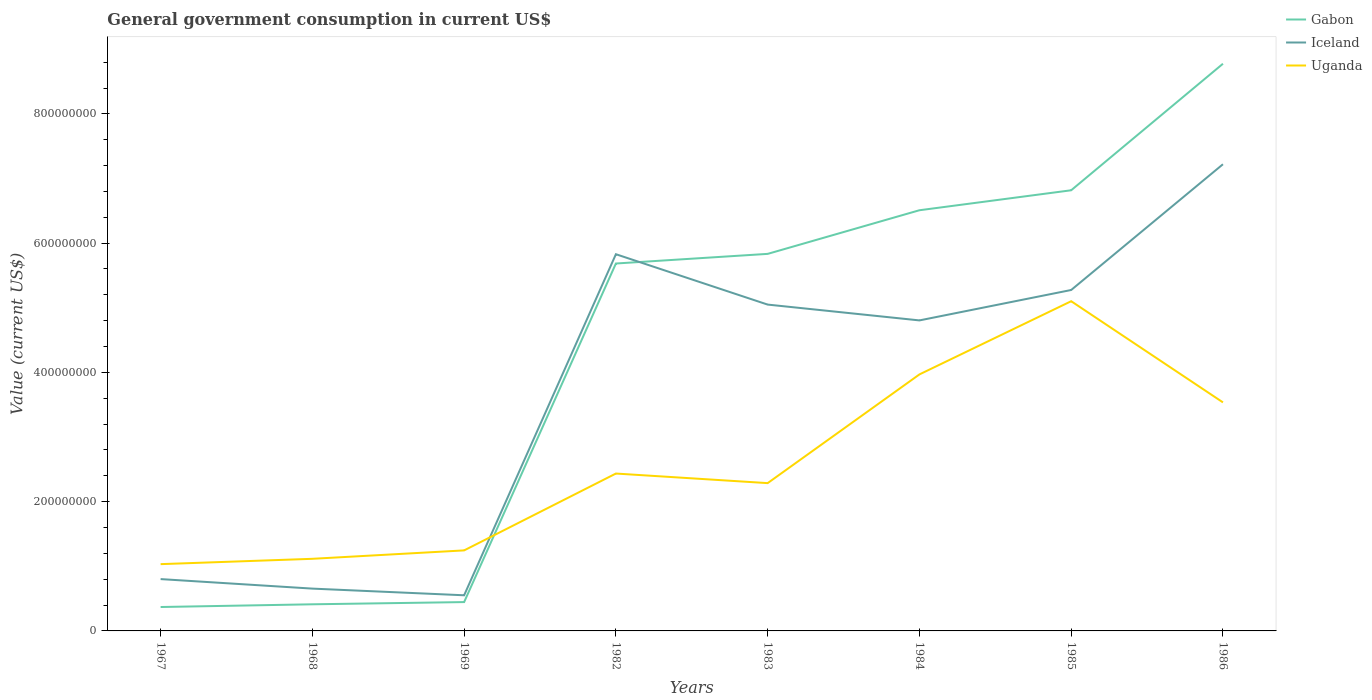Does the line corresponding to Iceland intersect with the line corresponding to Uganda?
Provide a short and direct response. Yes. Across all years, what is the maximum government conusmption in Gabon?
Provide a short and direct response. 3.70e+07. In which year was the government conusmption in Uganda maximum?
Your response must be concise. 1967. What is the total government conusmption in Iceland in the graph?
Give a very brief answer. 1.03e+07. What is the difference between the highest and the second highest government conusmption in Gabon?
Your response must be concise. 8.41e+08. Is the government conusmption in Uganda strictly greater than the government conusmption in Iceland over the years?
Make the answer very short. No. How many years are there in the graph?
Provide a succinct answer. 8. What is the difference between two consecutive major ticks on the Y-axis?
Make the answer very short. 2.00e+08. Does the graph contain any zero values?
Keep it short and to the point. No. Does the graph contain grids?
Give a very brief answer. No. Where does the legend appear in the graph?
Your answer should be compact. Top right. How many legend labels are there?
Give a very brief answer. 3. How are the legend labels stacked?
Offer a terse response. Vertical. What is the title of the graph?
Your answer should be compact. General government consumption in current US$. What is the label or title of the Y-axis?
Your response must be concise. Value (current US$). What is the Value (current US$) in Gabon in 1967?
Make the answer very short. 3.70e+07. What is the Value (current US$) of Iceland in 1967?
Your answer should be compact. 8.02e+07. What is the Value (current US$) in Uganda in 1967?
Keep it short and to the point. 1.03e+08. What is the Value (current US$) of Gabon in 1968?
Make the answer very short. 4.12e+07. What is the Value (current US$) in Iceland in 1968?
Give a very brief answer. 6.55e+07. What is the Value (current US$) of Uganda in 1968?
Offer a terse response. 1.12e+08. What is the Value (current US$) of Gabon in 1969?
Your answer should be compact. 4.46e+07. What is the Value (current US$) in Iceland in 1969?
Offer a terse response. 5.51e+07. What is the Value (current US$) of Uganda in 1969?
Ensure brevity in your answer.  1.25e+08. What is the Value (current US$) of Gabon in 1982?
Provide a short and direct response. 5.68e+08. What is the Value (current US$) in Iceland in 1982?
Provide a short and direct response. 5.83e+08. What is the Value (current US$) in Uganda in 1982?
Offer a very short reply. 2.44e+08. What is the Value (current US$) of Gabon in 1983?
Offer a very short reply. 5.83e+08. What is the Value (current US$) in Iceland in 1983?
Ensure brevity in your answer.  5.05e+08. What is the Value (current US$) in Uganda in 1983?
Provide a succinct answer. 2.29e+08. What is the Value (current US$) in Gabon in 1984?
Offer a very short reply. 6.51e+08. What is the Value (current US$) in Iceland in 1984?
Your answer should be compact. 4.80e+08. What is the Value (current US$) of Uganda in 1984?
Give a very brief answer. 3.97e+08. What is the Value (current US$) of Gabon in 1985?
Keep it short and to the point. 6.82e+08. What is the Value (current US$) of Iceland in 1985?
Your response must be concise. 5.27e+08. What is the Value (current US$) of Uganda in 1985?
Make the answer very short. 5.10e+08. What is the Value (current US$) of Gabon in 1986?
Offer a terse response. 8.78e+08. What is the Value (current US$) of Iceland in 1986?
Keep it short and to the point. 7.22e+08. What is the Value (current US$) in Uganda in 1986?
Provide a short and direct response. 3.54e+08. Across all years, what is the maximum Value (current US$) of Gabon?
Give a very brief answer. 8.78e+08. Across all years, what is the maximum Value (current US$) of Iceland?
Keep it short and to the point. 7.22e+08. Across all years, what is the maximum Value (current US$) of Uganda?
Provide a succinct answer. 5.10e+08. Across all years, what is the minimum Value (current US$) in Gabon?
Your answer should be compact. 3.70e+07. Across all years, what is the minimum Value (current US$) in Iceland?
Give a very brief answer. 5.51e+07. Across all years, what is the minimum Value (current US$) of Uganda?
Make the answer very short. 1.03e+08. What is the total Value (current US$) of Gabon in the graph?
Provide a short and direct response. 3.48e+09. What is the total Value (current US$) of Iceland in the graph?
Provide a short and direct response. 3.02e+09. What is the total Value (current US$) of Uganda in the graph?
Offer a very short reply. 2.07e+09. What is the difference between the Value (current US$) of Gabon in 1967 and that in 1968?
Your answer should be compact. -4.21e+06. What is the difference between the Value (current US$) of Iceland in 1967 and that in 1968?
Your answer should be compact. 1.47e+07. What is the difference between the Value (current US$) in Uganda in 1967 and that in 1968?
Provide a short and direct response. -8.26e+06. What is the difference between the Value (current US$) in Gabon in 1967 and that in 1969?
Your answer should be compact. -7.63e+06. What is the difference between the Value (current US$) of Iceland in 1967 and that in 1969?
Your answer should be compact. 2.50e+07. What is the difference between the Value (current US$) of Uganda in 1967 and that in 1969?
Provide a succinct answer. -2.13e+07. What is the difference between the Value (current US$) in Gabon in 1967 and that in 1982?
Keep it short and to the point. -5.31e+08. What is the difference between the Value (current US$) in Iceland in 1967 and that in 1982?
Ensure brevity in your answer.  -5.03e+08. What is the difference between the Value (current US$) in Uganda in 1967 and that in 1982?
Give a very brief answer. -1.40e+08. What is the difference between the Value (current US$) in Gabon in 1967 and that in 1983?
Provide a succinct answer. -5.46e+08. What is the difference between the Value (current US$) of Iceland in 1967 and that in 1983?
Provide a succinct answer. -4.25e+08. What is the difference between the Value (current US$) of Uganda in 1967 and that in 1983?
Make the answer very short. -1.25e+08. What is the difference between the Value (current US$) in Gabon in 1967 and that in 1984?
Provide a short and direct response. -6.14e+08. What is the difference between the Value (current US$) of Iceland in 1967 and that in 1984?
Provide a short and direct response. -4.00e+08. What is the difference between the Value (current US$) in Uganda in 1967 and that in 1984?
Your answer should be compact. -2.94e+08. What is the difference between the Value (current US$) of Gabon in 1967 and that in 1985?
Offer a terse response. -6.45e+08. What is the difference between the Value (current US$) in Iceland in 1967 and that in 1985?
Offer a terse response. -4.47e+08. What is the difference between the Value (current US$) in Uganda in 1967 and that in 1985?
Your answer should be compact. -4.07e+08. What is the difference between the Value (current US$) of Gabon in 1967 and that in 1986?
Ensure brevity in your answer.  -8.41e+08. What is the difference between the Value (current US$) in Iceland in 1967 and that in 1986?
Keep it short and to the point. -6.42e+08. What is the difference between the Value (current US$) in Uganda in 1967 and that in 1986?
Provide a succinct answer. -2.50e+08. What is the difference between the Value (current US$) of Gabon in 1968 and that in 1969?
Keep it short and to the point. -3.42e+06. What is the difference between the Value (current US$) in Iceland in 1968 and that in 1969?
Provide a succinct answer. 1.03e+07. What is the difference between the Value (current US$) of Uganda in 1968 and that in 1969?
Offer a very short reply. -1.30e+07. What is the difference between the Value (current US$) of Gabon in 1968 and that in 1982?
Make the answer very short. -5.27e+08. What is the difference between the Value (current US$) in Iceland in 1968 and that in 1982?
Your answer should be very brief. -5.17e+08. What is the difference between the Value (current US$) in Uganda in 1968 and that in 1982?
Your answer should be compact. -1.32e+08. What is the difference between the Value (current US$) of Gabon in 1968 and that in 1983?
Provide a short and direct response. -5.42e+08. What is the difference between the Value (current US$) of Iceland in 1968 and that in 1983?
Your answer should be very brief. -4.39e+08. What is the difference between the Value (current US$) in Uganda in 1968 and that in 1983?
Give a very brief answer. -1.17e+08. What is the difference between the Value (current US$) in Gabon in 1968 and that in 1984?
Your response must be concise. -6.10e+08. What is the difference between the Value (current US$) in Iceland in 1968 and that in 1984?
Provide a short and direct response. -4.15e+08. What is the difference between the Value (current US$) of Uganda in 1968 and that in 1984?
Your answer should be very brief. -2.85e+08. What is the difference between the Value (current US$) in Gabon in 1968 and that in 1985?
Ensure brevity in your answer.  -6.41e+08. What is the difference between the Value (current US$) of Iceland in 1968 and that in 1985?
Your answer should be compact. -4.62e+08. What is the difference between the Value (current US$) in Uganda in 1968 and that in 1985?
Provide a succinct answer. -3.99e+08. What is the difference between the Value (current US$) in Gabon in 1968 and that in 1986?
Your response must be concise. -8.36e+08. What is the difference between the Value (current US$) of Iceland in 1968 and that in 1986?
Your answer should be very brief. -6.57e+08. What is the difference between the Value (current US$) in Uganda in 1968 and that in 1986?
Keep it short and to the point. -2.42e+08. What is the difference between the Value (current US$) of Gabon in 1969 and that in 1982?
Offer a terse response. -5.24e+08. What is the difference between the Value (current US$) in Iceland in 1969 and that in 1982?
Make the answer very short. -5.28e+08. What is the difference between the Value (current US$) in Uganda in 1969 and that in 1982?
Ensure brevity in your answer.  -1.19e+08. What is the difference between the Value (current US$) in Gabon in 1969 and that in 1983?
Offer a very short reply. -5.39e+08. What is the difference between the Value (current US$) in Iceland in 1969 and that in 1983?
Provide a short and direct response. -4.50e+08. What is the difference between the Value (current US$) of Uganda in 1969 and that in 1983?
Your answer should be compact. -1.04e+08. What is the difference between the Value (current US$) of Gabon in 1969 and that in 1984?
Make the answer very short. -6.06e+08. What is the difference between the Value (current US$) in Iceland in 1969 and that in 1984?
Ensure brevity in your answer.  -4.25e+08. What is the difference between the Value (current US$) of Uganda in 1969 and that in 1984?
Offer a terse response. -2.72e+08. What is the difference between the Value (current US$) of Gabon in 1969 and that in 1985?
Your answer should be very brief. -6.37e+08. What is the difference between the Value (current US$) of Iceland in 1969 and that in 1985?
Your answer should be very brief. -4.72e+08. What is the difference between the Value (current US$) in Uganda in 1969 and that in 1985?
Your answer should be compact. -3.86e+08. What is the difference between the Value (current US$) in Gabon in 1969 and that in 1986?
Your answer should be compact. -8.33e+08. What is the difference between the Value (current US$) of Iceland in 1969 and that in 1986?
Your response must be concise. -6.67e+08. What is the difference between the Value (current US$) of Uganda in 1969 and that in 1986?
Give a very brief answer. -2.29e+08. What is the difference between the Value (current US$) of Gabon in 1982 and that in 1983?
Ensure brevity in your answer.  -1.49e+07. What is the difference between the Value (current US$) in Iceland in 1982 and that in 1983?
Offer a very short reply. 7.79e+07. What is the difference between the Value (current US$) of Uganda in 1982 and that in 1983?
Offer a terse response. 1.48e+07. What is the difference between the Value (current US$) of Gabon in 1982 and that in 1984?
Provide a short and direct response. -8.24e+07. What is the difference between the Value (current US$) in Iceland in 1982 and that in 1984?
Make the answer very short. 1.02e+08. What is the difference between the Value (current US$) in Uganda in 1982 and that in 1984?
Offer a very short reply. -1.53e+08. What is the difference between the Value (current US$) in Gabon in 1982 and that in 1985?
Your answer should be very brief. -1.13e+08. What is the difference between the Value (current US$) in Iceland in 1982 and that in 1985?
Provide a short and direct response. 5.54e+07. What is the difference between the Value (current US$) in Uganda in 1982 and that in 1985?
Keep it short and to the point. -2.67e+08. What is the difference between the Value (current US$) of Gabon in 1982 and that in 1986?
Provide a short and direct response. -3.09e+08. What is the difference between the Value (current US$) in Iceland in 1982 and that in 1986?
Your answer should be very brief. -1.39e+08. What is the difference between the Value (current US$) in Uganda in 1982 and that in 1986?
Provide a succinct answer. -1.10e+08. What is the difference between the Value (current US$) of Gabon in 1983 and that in 1984?
Your answer should be very brief. -6.75e+07. What is the difference between the Value (current US$) of Iceland in 1983 and that in 1984?
Keep it short and to the point. 2.45e+07. What is the difference between the Value (current US$) in Uganda in 1983 and that in 1984?
Your answer should be compact. -1.68e+08. What is the difference between the Value (current US$) of Gabon in 1983 and that in 1985?
Your response must be concise. -9.84e+07. What is the difference between the Value (current US$) in Iceland in 1983 and that in 1985?
Ensure brevity in your answer.  -2.26e+07. What is the difference between the Value (current US$) of Uganda in 1983 and that in 1985?
Provide a short and direct response. -2.81e+08. What is the difference between the Value (current US$) in Gabon in 1983 and that in 1986?
Make the answer very short. -2.94e+08. What is the difference between the Value (current US$) in Iceland in 1983 and that in 1986?
Give a very brief answer. -2.17e+08. What is the difference between the Value (current US$) of Uganda in 1983 and that in 1986?
Your response must be concise. -1.25e+08. What is the difference between the Value (current US$) in Gabon in 1984 and that in 1985?
Your answer should be compact. -3.09e+07. What is the difference between the Value (current US$) of Iceland in 1984 and that in 1985?
Your response must be concise. -4.71e+07. What is the difference between the Value (current US$) of Uganda in 1984 and that in 1985?
Offer a very short reply. -1.13e+08. What is the difference between the Value (current US$) of Gabon in 1984 and that in 1986?
Provide a short and direct response. -2.27e+08. What is the difference between the Value (current US$) in Iceland in 1984 and that in 1986?
Offer a terse response. -2.42e+08. What is the difference between the Value (current US$) in Uganda in 1984 and that in 1986?
Your response must be concise. 4.33e+07. What is the difference between the Value (current US$) of Gabon in 1985 and that in 1986?
Provide a short and direct response. -1.96e+08. What is the difference between the Value (current US$) in Iceland in 1985 and that in 1986?
Provide a short and direct response. -1.95e+08. What is the difference between the Value (current US$) in Uganda in 1985 and that in 1986?
Provide a succinct answer. 1.57e+08. What is the difference between the Value (current US$) of Gabon in 1967 and the Value (current US$) of Iceland in 1968?
Offer a very short reply. -2.85e+07. What is the difference between the Value (current US$) in Gabon in 1967 and the Value (current US$) in Uganda in 1968?
Provide a succinct answer. -7.46e+07. What is the difference between the Value (current US$) of Iceland in 1967 and the Value (current US$) of Uganda in 1968?
Make the answer very short. -3.14e+07. What is the difference between the Value (current US$) of Gabon in 1967 and the Value (current US$) of Iceland in 1969?
Offer a terse response. -1.81e+07. What is the difference between the Value (current US$) in Gabon in 1967 and the Value (current US$) in Uganda in 1969?
Your answer should be very brief. -8.76e+07. What is the difference between the Value (current US$) in Iceland in 1967 and the Value (current US$) in Uganda in 1969?
Offer a very short reply. -4.44e+07. What is the difference between the Value (current US$) in Gabon in 1967 and the Value (current US$) in Iceland in 1982?
Offer a terse response. -5.46e+08. What is the difference between the Value (current US$) of Gabon in 1967 and the Value (current US$) of Uganda in 1982?
Give a very brief answer. -2.07e+08. What is the difference between the Value (current US$) in Iceland in 1967 and the Value (current US$) in Uganda in 1982?
Provide a short and direct response. -1.63e+08. What is the difference between the Value (current US$) of Gabon in 1967 and the Value (current US$) of Iceland in 1983?
Keep it short and to the point. -4.68e+08. What is the difference between the Value (current US$) of Gabon in 1967 and the Value (current US$) of Uganda in 1983?
Keep it short and to the point. -1.92e+08. What is the difference between the Value (current US$) in Iceland in 1967 and the Value (current US$) in Uganda in 1983?
Provide a succinct answer. -1.48e+08. What is the difference between the Value (current US$) of Gabon in 1967 and the Value (current US$) of Iceland in 1984?
Provide a succinct answer. -4.43e+08. What is the difference between the Value (current US$) in Gabon in 1967 and the Value (current US$) in Uganda in 1984?
Your response must be concise. -3.60e+08. What is the difference between the Value (current US$) in Iceland in 1967 and the Value (current US$) in Uganda in 1984?
Provide a succinct answer. -3.17e+08. What is the difference between the Value (current US$) of Gabon in 1967 and the Value (current US$) of Iceland in 1985?
Provide a succinct answer. -4.90e+08. What is the difference between the Value (current US$) of Gabon in 1967 and the Value (current US$) of Uganda in 1985?
Your response must be concise. -4.73e+08. What is the difference between the Value (current US$) of Iceland in 1967 and the Value (current US$) of Uganda in 1985?
Make the answer very short. -4.30e+08. What is the difference between the Value (current US$) in Gabon in 1967 and the Value (current US$) in Iceland in 1986?
Offer a terse response. -6.85e+08. What is the difference between the Value (current US$) in Gabon in 1967 and the Value (current US$) in Uganda in 1986?
Your response must be concise. -3.17e+08. What is the difference between the Value (current US$) in Iceland in 1967 and the Value (current US$) in Uganda in 1986?
Give a very brief answer. -2.73e+08. What is the difference between the Value (current US$) in Gabon in 1968 and the Value (current US$) in Iceland in 1969?
Offer a terse response. -1.39e+07. What is the difference between the Value (current US$) of Gabon in 1968 and the Value (current US$) of Uganda in 1969?
Give a very brief answer. -8.34e+07. What is the difference between the Value (current US$) in Iceland in 1968 and the Value (current US$) in Uganda in 1969?
Keep it short and to the point. -5.91e+07. What is the difference between the Value (current US$) of Gabon in 1968 and the Value (current US$) of Iceland in 1982?
Ensure brevity in your answer.  -5.42e+08. What is the difference between the Value (current US$) in Gabon in 1968 and the Value (current US$) in Uganda in 1982?
Offer a very short reply. -2.02e+08. What is the difference between the Value (current US$) in Iceland in 1968 and the Value (current US$) in Uganda in 1982?
Keep it short and to the point. -1.78e+08. What is the difference between the Value (current US$) in Gabon in 1968 and the Value (current US$) in Iceland in 1983?
Offer a very short reply. -4.64e+08. What is the difference between the Value (current US$) in Gabon in 1968 and the Value (current US$) in Uganda in 1983?
Offer a terse response. -1.87e+08. What is the difference between the Value (current US$) in Iceland in 1968 and the Value (current US$) in Uganda in 1983?
Provide a short and direct response. -1.63e+08. What is the difference between the Value (current US$) of Gabon in 1968 and the Value (current US$) of Iceland in 1984?
Give a very brief answer. -4.39e+08. What is the difference between the Value (current US$) in Gabon in 1968 and the Value (current US$) in Uganda in 1984?
Your answer should be very brief. -3.56e+08. What is the difference between the Value (current US$) in Iceland in 1968 and the Value (current US$) in Uganda in 1984?
Provide a succinct answer. -3.31e+08. What is the difference between the Value (current US$) of Gabon in 1968 and the Value (current US$) of Iceland in 1985?
Offer a terse response. -4.86e+08. What is the difference between the Value (current US$) of Gabon in 1968 and the Value (current US$) of Uganda in 1985?
Your answer should be compact. -4.69e+08. What is the difference between the Value (current US$) in Iceland in 1968 and the Value (current US$) in Uganda in 1985?
Keep it short and to the point. -4.45e+08. What is the difference between the Value (current US$) of Gabon in 1968 and the Value (current US$) of Iceland in 1986?
Ensure brevity in your answer.  -6.81e+08. What is the difference between the Value (current US$) of Gabon in 1968 and the Value (current US$) of Uganda in 1986?
Give a very brief answer. -3.12e+08. What is the difference between the Value (current US$) in Iceland in 1968 and the Value (current US$) in Uganda in 1986?
Offer a terse response. -2.88e+08. What is the difference between the Value (current US$) of Gabon in 1969 and the Value (current US$) of Iceland in 1982?
Provide a succinct answer. -5.38e+08. What is the difference between the Value (current US$) of Gabon in 1969 and the Value (current US$) of Uganda in 1982?
Your response must be concise. -1.99e+08. What is the difference between the Value (current US$) in Iceland in 1969 and the Value (current US$) in Uganda in 1982?
Make the answer very short. -1.88e+08. What is the difference between the Value (current US$) in Gabon in 1969 and the Value (current US$) in Iceland in 1983?
Your answer should be very brief. -4.60e+08. What is the difference between the Value (current US$) in Gabon in 1969 and the Value (current US$) in Uganda in 1983?
Give a very brief answer. -1.84e+08. What is the difference between the Value (current US$) of Iceland in 1969 and the Value (current US$) of Uganda in 1983?
Ensure brevity in your answer.  -1.74e+08. What is the difference between the Value (current US$) of Gabon in 1969 and the Value (current US$) of Iceland in 1984?
Offer a terse response. -4.36e+08. What is the difference between the Value (current US$) in Gabon in 1969 and the Value (current US$) in Uganda in 1984?
Your response must be concise. -3.52e+08. What is the difference between the Value (current US$) in Iceland in 1969 and the Value (current US$) in Uganda in 1984?
Offer a very short reply. -3.42e+08. What is the difference between the Value (current US$) of Gabon in 1969 and the Value (current US$) of Iceland in 1985?
Offer a terse response. -4.83e+08. What is the difference between the Value (current US$) of Gabon in 1969 and the Value (current US$) of Uganda in 1985?
Offer a very short reply. -4.66e+08. What is the difference between the Value (current US$) in Iceland in 1969 and the Value (current US$) in Uganda in 1985?
Provide a short and direct response. -4.55e+08. What is the difference between the Value (current US$) in Gabon in 1969 and the Value (current US$) in Iceland in 1986?
Provide a short and direct response. -6.77e+08. What is the difference between the Value (current US$) in Gabon in 1969 and the Value (current US$) in Uganda in 1986?
Offer a terse response. -3.09e+08. What is the difference between the Value (current US$) of Iceland in 1969 and the Value (current US$) of Uganda in 1986?
Your response must be concise. -2.98e+08. What is the difference between the Value (current US$) in Gabon in 1982 and the Value (current US$) in Iceland in 1983?
Make the answer very short. 6.36e+07. What is the difference between the Value (current US$) in Gabon in 1982 and the Value (current US$) in Uganda in 1983?
Offer a very short reply. 3.40e+08. What is the difference between the Value (current US$) in Iceland in 1982 and the Value (current US$) in Uganda in 1983?
Your answer should be very brief. 3.54e+08. What is the difference between the Value (current US$) in Gabon in 1982 and the Value (current US$) in Iceland in 1984?
Give a very brief answer. 8.80e+07. What is the difference between the Value (current US$) of Gabon in 1982 and the Value (current US$) of Uganda in 1984?
Give a very brief answer. 1.72e+08. What is the difference between the Value (current US$) of Iceland in 1982 and the Value (current US$) of Uganda in 1984?
Your answer should be compact. 1.86e+08. What is the difference between the Value (current US$) of Gabon in 1982 and the Value (current US$) of Iceland in 1985?
Give a very brief answer. 4.10e+07. What is the difference between the Value (current US$) of Gabon in 1982 and the Value (current US$) of Uganda in 1985?
Keep it short and to the point. 5.83e+07. What is the difference between the Value (current US$) of Iceland in 1982 and the Value (current US$) of Uganda in 1985?
Ensure brevity in your answer.  7.27e+07. What is the difference between the Value (current US$) of Gabon in 1982 and the Value (current US$) of Iceland in 1986?
Make the answer very short. -1.54e+08. What is the difference between the Value (current US$) in Gabon in 1982 and the Value (current US$) in Uganda in 1986?
Ensure brevity in your answer.  2.15e+08. What is the difference between the Value (current US$) in Iceland in 1982 and the Value (current US$) in Uganda in 1986?
Your answer should be very brief. 2.29e+08. What is the difference between the Value (current US$) in Gabon in 1983 and the Value (current US$) in Iceland in 1984?
Offer a very short reply. 1.03e+08. What is the difference between the Value (current US$) of Gabon in 1983 and the Value (current US$) of Uganda in 1984?
Your response must be concise. 1.87e+08. What is the difference between the Value (current US$) of Iceland in 1983 and the Value (current US$) of Uganda in 1984?
Your answer should be very brief. 1.08e+08. What is the difference between the Value (current US$) in Gabon in 1983 and the Value (current US$) in Iceland in 1985?
Ensure brevity in your answer.  5.59e+07. What is the difference between the Value (current US$) in Gabon in 1983 and the Value (current US$) in Uganda in 1985?
Give a very brief answer. 7.32e+07. What is the difference between the Value (current US$) in Iceland in 1983 and the Value (current US$) in Uganda in 1985?
Make the answer very short. -5.23e+06. What is the difference between the Value (current US$) in Gabon in 1983 and the Value (current US$) in Iceland in 1986?
Keep it short and to the point. -1.39e+08. What is the difference between the Value (current US$) in Gabon in 1983 and the Value (current US$) in Uganda in 1986?
Provide a succinct answer. 2.30e+08. What is the difference between the Value (current US$) of Iceland in 1983 and the Value (current US$) of Uganda in 1986?
Provide a short and direct response. 1.51e+08. What is the difference between the Value (current US$) in Gabon in 1984 and the Value (current US$) in Iceland in 1985?
Give a very brief answer. 1.23e+08. What is the difference between the Value (current US$) in Gabon in 1984 and the Value (current US$) in Uganda in 1985?
Provide a succinct answer. 1.41e+08. What is the difference between the Value (current US$) of Iceland in 1984 and the Value (current US$) of Uganda in 1985?
Your answer should be very brief. -2.97e+07. What is the difference between the Value (current US$) in Gabon in 1984 and the Value (current US$) in Iceland in 1986?
Make the answer very short. -7.12e+07. What is the difference between the Value (current US$) of Gabon in 1984 and the Value (current US$) of Uganda in 1986?
Your answer should be very brief. 2.97e+08. What is the difference between the Value (current US$) of Iceland in 1984 and the Value (current US$) of Uganda in 1986?
Ensure brevity in your answer.  1.27e+08. What is the difference between the Value (current US$) of Gabon in 1985 and the Value (current US$) of Iceland in 1986?
Ensure brevity in your answer.  -4.03e+07. What is the difference between the Value (current US$) in Gabon in 1985 and the Value (current US$) in Uganda in 1986?
Make the answer very short. 3.28e+08. What is the difference between the Value (current US$) of Iceland in 1985 and the Value (current US$) of Uganda in 1986?
Offer a very short reply. 1.74e+08. What is the average Value (current US$) of Gabon per year?
Give a very brief answer. 4.36e+08. What is the average Value (current US$) in Iceland per year?
Give a very brief answer. 3.77e+08. What is the average Value (current US$) in Uganda per year?
Ensure brevity in your answer.  2.59e+08. In the year 1967, what is the difference between the Value (current US$) in Gabon and Value (current US$) in Iceland?
Keep it short and to the point. -4.32e+07. In the year 1967, what is the difference between the Value (current US$) of Gabon and Value (current US$) of Uganda?
Give a very brief answer. -6.63e+07. In the year 1967, what is the difference between the Value (current US$) in Iceland and Value (current US$) in Uganda?
Your response must be concise. -2.31e+07. In the year 1968, what is the difference between the Value (current US$) of Gabon and Value (current US$) of Iceland?
Offer a terse response. -2.43e+07. In the year 1968, what is the difference between the Value (current US$) of Gabon and Value (current US$) of Uganda?
Give a very brief answer. -7.04e+07. In the year 1968, what is the difference between the Value (current US$) in Iceland and Value (current US$) in Uganda?
Make the answer very short. -4.61e+07. In the year 1969, what is the difference between the Value (current US$) in Gabon and Value (current US$) in Iceland?
Keep it short and to the point. -1.05e+07. In the year 1969, what is the difference between the Value (current US$) of Gabon and Value (current US$) of Uganda?
Keep it short and to the point. -8.00e+07. In the year 1969, what is the difference between the Value (current US$) in Iceland and Value (current US$) in Uganda?
Provide a short and direct response. -6.95e+07. In the year 1982, what is the difference between the Value (current US$) of Gabon and Value (current US$) of Iceland?
Ensure brevity in your answer.  -1.44e+07. In the year 1982, what is the difference between the Value (current US$) of Gabon and Value (current US$) of Uganda?
Provide a short and direct response. 3.25e+08. In the year 1982, what is the difference between the Value (current US$) in Iceland and Value (current US$) in Uganda?
Ensure brevity in your answer.  3.39e+08. In the year 1983, what is the difference between the Value (current US$) of Gabon and Value (current US$) of Iceland?
Keep it short and to the point. 7.85e+07. In the year 1983, what is the difference between the Value (current US$) in Gabon and Value (current US$) in Uganda?
Your answer should be very brief. 3.55e+08. In the year 1983, what is the difference between the Value (current US$) in Iceland and Value (current US$) in Uganda?
Ensure brevity in your answer.  2.76e+08. In the year 1984, what is the difference between the Value (current US$) in Gabon and Value (current US$) in Iceland?
Keep it short and to the point. 1.70e+08. In the year 1984, what is the difference between the Value (current US$) of Gabon and Value (current US$) of Uganda?
Provide a short and direct response. 2.54e+08. In the year 1984, what is the difference between the Value (current US$) in Iceland and Value (current US$) in Uganda?
Your answer should be compact. 8.36e+07. In the year 1985, what is the difference between the Value (current US$) in Gabon and Value (current US$) in Iceland?
Offer a very short reply. 1.54e+08. In the year 1985, what is the difference between the Value (current US$) in Gabon and Value (current US$) in Uganda?
Provide a succinct answer. 1.72e+08. In the year 1985, what is the difference between the Value (current US$) in Iceland and Value (current US$) in Uganda?
Give a very brief answer. 1.74e+07. In the year 1986, what is the difference between the Value (current US$) in Gabon and Value (current US$) in Iceland?
Ensure brevity in your answer.  1.56e+08. In the year 1986, what is the difference between the Value (current US$) of Gabon and Value (current US$) of Uganda?
Provide a short and direct response. 5.24e+08. In the year 1986, what is the difference between the Value (current US$) of Iceland and Value (current US$) of Uganda?
Your response must be concise. 3.68e+08. What is the ratio of the Value (current US$) in Gabon in 1967 to that in 1968?
Your answer should be very brief. 0.9. What is the ratio of the Value (current US$) of Iceland in 1967 to that in 1968?
Ensure brevity in your answer.  1.22. What is the ratio of the Value (current US$) in Uganda in 1967 to that in 1968?
Your answer should be compact. 0.93. What is the ratio of the Value (current US$) in Gabon in 1967 to that in 1969?
Your answer should be compact. 0.83. What is the ratio of the Value (current US$) in Iceland in 1967 to that in 1969?
Offer a very short reply. 1.45. What is the ratio of the Value (current US$) in Uganda in 1967 to that in 1969?
Your answer should be very brief. 0.83. What is the ratio of the Value (current US$) of Gabon in 1967 to that in 1982?
Make the answer very short. 0.07. What is the ratio of the Value (current US$) of Iceland in 1967 to that in 1982?
Give a very brief answer. 0.14. What is the ratio of the Value (current US$) in Uganda in 1967 to that in 1982?
Make the answer very short. 0.42. What is the ratio of the Value (current US$) in Gabon in 1967 to that in 1983?
Keep it short and to the point. 0.06. What is the ratio of the Value (current US$) in Iceland in 1967 to that in 1983?
Your answer should be very brief. 0.16. What is the ratio of the Value (current US$) of Uganda in 1967 to that in 1983?
Your response must be concise. 0.45. What is the ratio of the Value (current US$) of Gabon in 1967 to that in 1984?
Give a very brief answer. 0.06. What is the ratio of the Value (current US$) in Iceland in 1967 to that in 1984?
Offer a very short reply. 0.17. What is the ratio of the Value (current US$) of Uganda in 1967 to that in 1984?
Make the answer very short. 0.26. What is the ratio of the Value (current US$) in Gabon in 1967 to that in 1985?
Your answer should be very brief. 0.05. What is the ratio of the Value (current US$) of Iceland in 1967 to that in 1985?
Your answer should be compact. 0.15. What is the ratio of the Value (current US$) of Uganda in 1967 to that in 1985?
Give a very brief answer. 0.2. What is the ratio of the Value (current US$) in Gabon in 1967 to that in 1986?
Your answer should be very brief. 0.04. What is the ratio of the Value (current US$) of Uganda in 1967 to that in 1986?
Make the answer very short. 0.29. What is the ratio of the Value (current US$) in Gabon in 1968 to that in 1969?
Your answer should be compact. 0.92. What is the ratio of the Value (current US$) of Iceland in 1968 to that in 1969?
Your answer should be very brief. 1.19. What is the ratio of the Value (current US$) in Uganda in 1968 to that in 1969?
Provide a short and direct response. 0.9. What is the ratio of the Value (current US$) in Gabon in 1968 to that in 1982?
Ensure brevity in your answer.  0.07. What is the ratio of the Value (current US$) of Iceland in 1968 to that in 1982?
Your answer should be very brief. 0.11. What is the ratio of the Value (current US$) in Uganda in 1968 to that in 1982?
Your response must be concise. 0.46. What is the ratio of the Value (current US$) in Gabon in 1968 to that in 1983?
Your answer should be compact. 0.07. What is the ratio of the Value (current US$) in Iceland in 1968 to that in 1983?
Offer a terse response. 0.13. What is the ratio of the Value (current US$) of Uganda in 1968 to that in 1983?
Provide a succinct answer. 0.49. What is the ratio of the Value (current US$) of Gabon in 1968 to that in 1984?
Your response must be concise. 0.06. What is the ratio of the Value (current US$) of Iceland in 1968 to that in 1984?
Make the answer very short. 0.14. What is the ratio of the Value (current US$) in Uganda in 1968 to that in 1984?
Your response must be concise. 0.28. What is the ratio of the Value (current US$) in Gabon in 1968 to that in 1985?
Your answer should be very brief. 0.06. What is the ratio of the Value (current US$) in Iceland in 1968 to that in 1985?
Provide a succinct answer. 0.12. What is the ratio of the Value (current US$) of Uganda in 1968 to that in 1985?
Your answer should be very brief. 0.22. What is the ratio of the Value (current US$) of Gabon in 1968 to that in 1986?
Offer a terse response. 0.05. What is the ratio of the Value (current US$) in Iceland in 1968 to that in 1986?
Provide a short and direct response. 0.09. What is the ratio of the Value (current US$) of Uganda in 1968 to that in 1986?
Make the answer very short. 0.32. What is the ratio of the Value (current US$) in Gabon in 1969 to that in 1982?
Keep it short and to the point. 0.08. What is the ratio of the Value (current US$) in Iceland in 1969 to that in 1982?
Your response must be concise. 0.09. What is the ratio of the Value (current US$) of Uganda in 1969 to that in 1982?
Your answer should be compact. 0.51. What is the ratio of the Value (current US$) of Gabon in 1969 to that in 1983?
Make the answer very short. 0.08. What is the ratio of the Value (current US$) in Iceland in 1969 to that in 1983?
Your response must be concise. 0.11. What is the ratio of the Value (current US$) of Uganda in 1969 to that in 1983?
Your response must be concise. 0.54. What is the ratio of the Value (current US$) of Gabon in 1969 to that in 1984?
Your answer should be compact. 0.07. What is the ratio of the Value (current US$) in Iceland in 1969 to that in 1984?
Your response must be concise. 0.11. What is the ratio of the Value (current US$) of Uganda in 1969 to that in 1984?
Offer a very short reply. 0.31. What is the ratio of the Value (current US$) in Gabon in 1969 to that in 1985?
Give a very brief answer. 0.07. What is the ratio of the Value (current US$) of Iceland in 1969 to that in 1985?
Give a very brief answer. 0.1. What is the ratio of the Value (current US$) in Uganda in 1969 to that in 1985?
Offer a terse response. 0.24. What is the ratio of the Value (current US$) in Gabon in 1969 to that in 1986?
Your answer should be compact. 0.05. What is the ratio of the Value (current US$) of Iceland in 1969 to that in 1986?
Provide a short and direct response. 0.08. What is the ratio of the Value (current US$) in Uganda in 1969 to that in 1986?
Your answer should be compact. 0.35. What is the ratio of the Value (current US$) of Gabon in 1982 to that in 1983?
Ensure brevity in your answer.  0.97. What is the ratio of the Value (current US$) of Iceland in 1982 to that in 1983?
Your answer should be very brief. 1.15. What is the ratio of the Value (current US$) of Uganda in 1982 to that in 1983?
Offer a very short reply. 1.06. What is the ratio of the Value (current US$) of Gabon in 1982 to that in 1984?
Provide a succinct answer. 0.87. What is the ratio of the Value (current US$) of Iceland in 1982 to that in 1984?
Make the answer very short. 1.21. What is the ratio of the Value (current US$) in Uganda in 1982 to that in 1984?
Make the answer very short. 0.61. What is the ratio of the Value (current US$) in Gabon in 1982 to that in 1985?
Offer a very short reply. 0.83. What is the ratio of the Value (current US$) of Iceland in 1982 to that in 1985?
Provide a succinct answer. 1.1. What is the ratio of the Value (current US$) of Uganda in 1982 to that in 1985?
Provide a succinct answer. 0.48. What is the ratio of the Value (current US$) in Gabon in 1982 to that in 1986?
Provide a succinct answer. 0.65. What is the ratio of the Value (current US$) of Iceland in 1982 to that in 1986?
Provide a succinct answer. 0.81. What is the ratio of the Value (current US$) of Uganda in 1982 to that in 1986?
Give a very brief answer. 0.69. What is the ratio of the Value (current US$) in Gabon in 1983 to that in 1984?
Your response must be concise. 0.9. What is the ratio of the Value (current US$) of Iceland in 1983 to that in 1984?
Offer a very short reply. 1.05. What is the ratio of the Value (current US$) in Uganda in 1983 to that in 1984?
Your answer should be very brief. 0.58. What is the ratio of the Value (current US$) in Gabon in 1983 to that in 1985?
Provide a succinct answer. 0.86. What is the ratio of the Value (current US$) of Iceland in 1983 to that in 1985?
Ensure brevity in your answer.  0.96. What is the ratio of the Value (current US$) of Uganda in 1983 to that in 1985?
Your answer should be very brief. 0.45. What is the ratio of the Value (current US$) in Gabon in 1983 to that in 1986?
Give a very brief answer. 0.66. What is the ratio of the Value (current US$) of Iceland in 1983 to that in 1986?
Your answer should be very brief. 0.7. What is the ratio of the Value (current US$) in Uganda in 1983 to that in 1986?
Ensure brevity in your answer.  0.65. What is the ratio of the Value (current US$) of Gabon in 1984 to that in 1985?
Keep it short and to the point. 0.95. What is the ratio of the Value (current US$) of Iceland in 1984 to that in 1985?
Your answer should be very brief. 0.91. What is the ratio of the Value (current US$) in Uganda in 1984 to that in 1985?
Your response must be concise. 0.78. What is the ratio of the Value (current US$) of Gabon in 1984 to that in 1986?
Provide a succinct answer. 0.74. What is the ratio of the Value (current US$) in Iceland in 1984 to that in 1986?
Give a very brief answer. 0.67. What is the ratio of the Value (current US$) in Uganda in 1984 to that in 1986?
Offer a terse response. 1.12. What is the ratio of the Value (current US$) in Gabon in 1985 to that in 1986?
Provide a short and direct response. 0.78. What is the ratio of the Value (current US$) of Iceland in 1985 to that in 1986?
Give a very brief answer. 0.73. What is the ratio of the Value (current US$) in Uganda in 1985 to that in 1986?
Your answer should be very brief. 1.44. What is the difference between the highest and the second highest Value (current US$) in Gabon?
Give a very brief answer. 1.96e+08. What is the difference between the highest and the second highest Value (current US$) of Iceland?
Ensure brevity in your answer.  1.39e+08. What is the difference between the highest and the second highest Value (current US$) of Uganda?
Offer a very short reply. 1.13e+08. What is the difference between the highest and the lowest Value (current US$) in Gabon?
Provide a succinct answer. 8.41e+08. What is the difference between the highest and the lowest Value (current US$) in Iceland?
Offer a terse response. 6.67e+08. What is the difference between the highest and the lowest Value (current US$) in Uganda?
Offer a very short reply. 4.07e+08. 